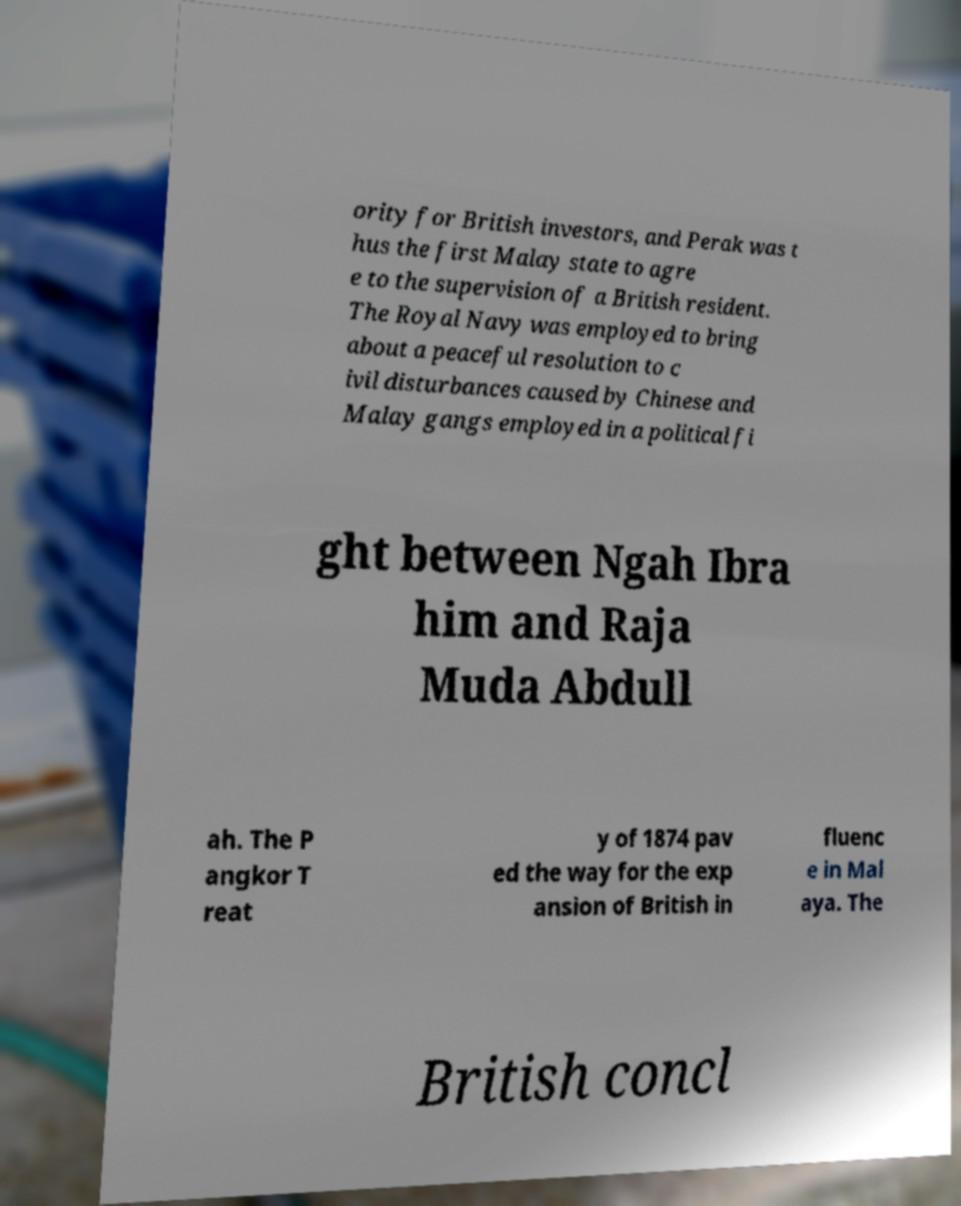Please read and relay the text visible in this image. What does it say? ority for British investors, and Perak was t hus the first Malay state to agre e to the supervision of a British resident. The Royal Navy was employed to bring about a peaceful resolution to c ivil disturbances caused by Chinese and Malay gangs employed in a political fi ght between Ngah Ibra him and Raja Muda Abdull ah. The P angkor T reat y of 1874 pav ed the way for the exp ansion of British in fluenc e in Mal aya. The British concl 